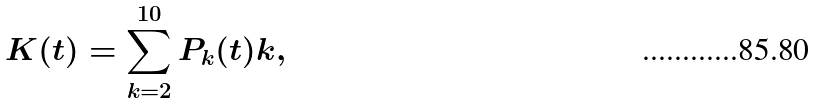Convert formula to latex. <formula><loc_0><loc_0><loc_500><loc_500>K ( t ) = \sum _ { k = 2 } ^ { 1 0 } P _ { k } ( t ) k ,</formula> 